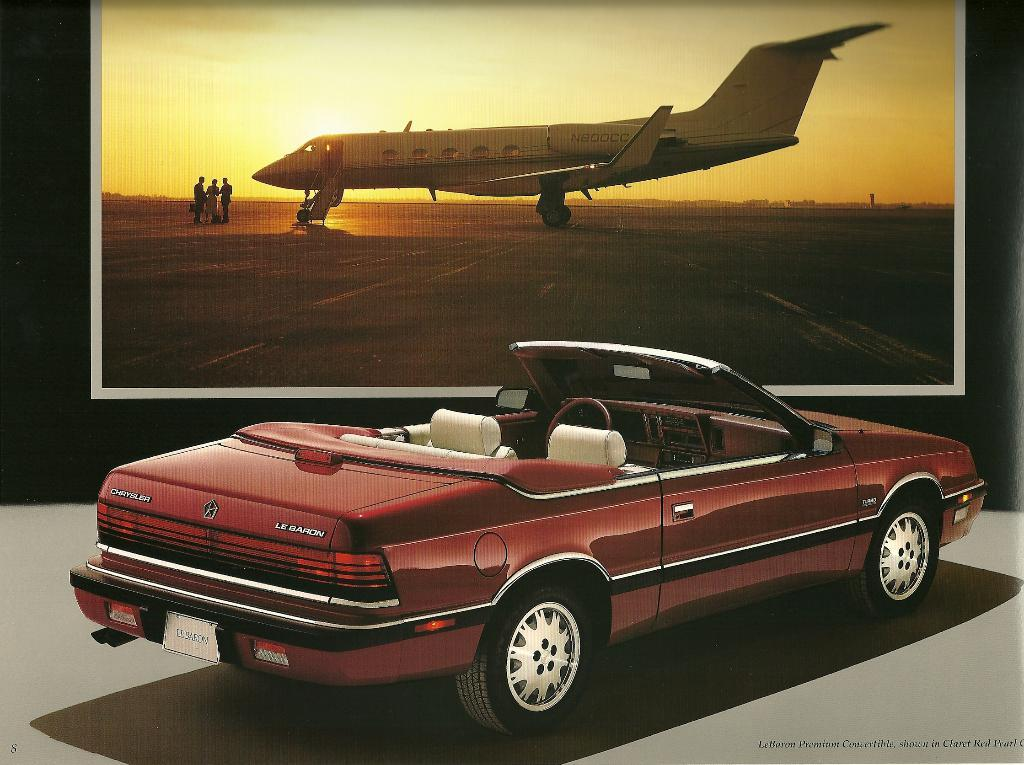<image>
Summarize the visual content of the image. A Chrysler Le Barron convertible is parked in front of a picture of a jet. 